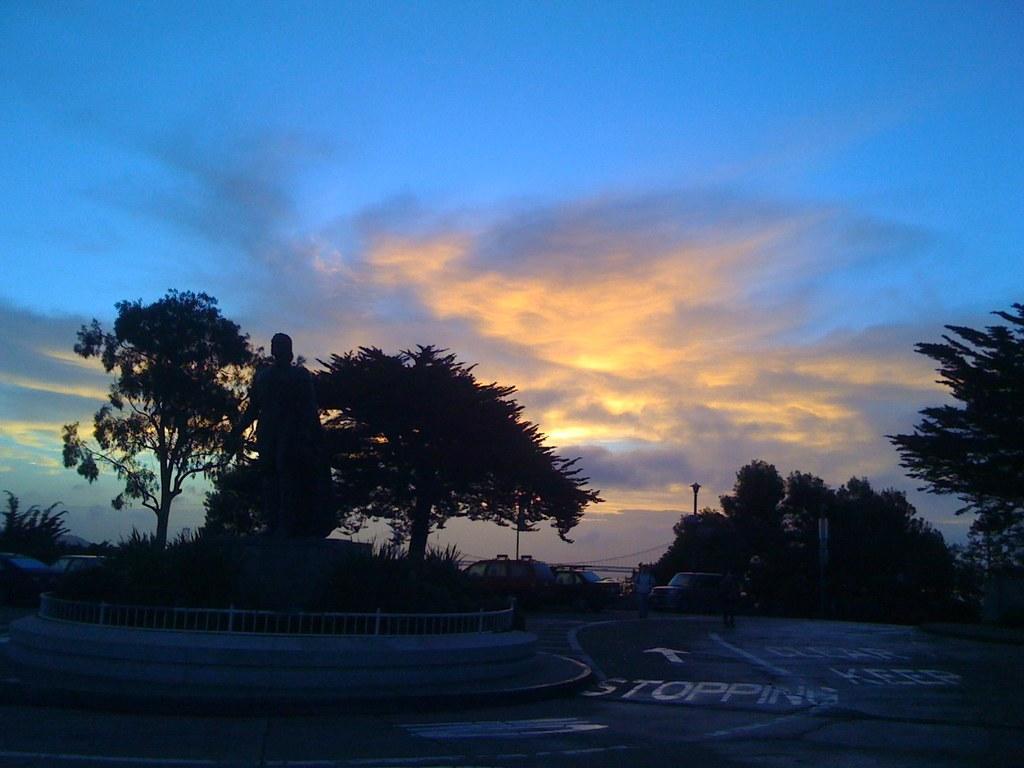Describe this image in one or two sentences. In this image we can see a statue, railing, there are few vehicles, people, some text and symbol on the road, there are few trees, a pole and the sky with clouds in the background. 